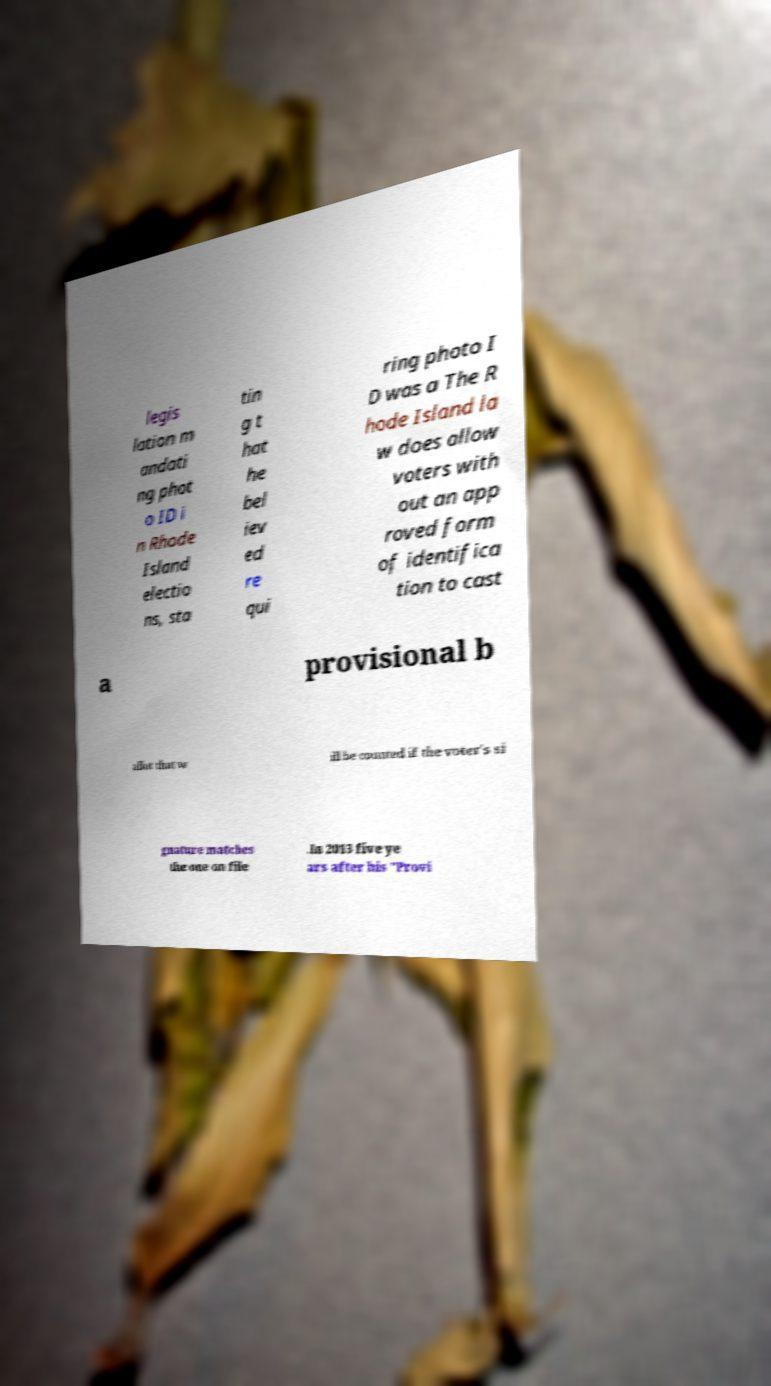Can you read and provide the text displayed in the image?This photo seems to have some interesting text. Can you extract and type it out for me? legis lation m andati ng phot o ID i n Rhode Island electio ns, sta tin g t hat he bel iev ed re qui ring photo I D was a The R hode Island la w does allow voters with out an app roved form of identifica tion to cast a provisional b allot that w ill be counted if the voter's si gnature matches the one on file .In 2013 five ye ars after his "Provi 